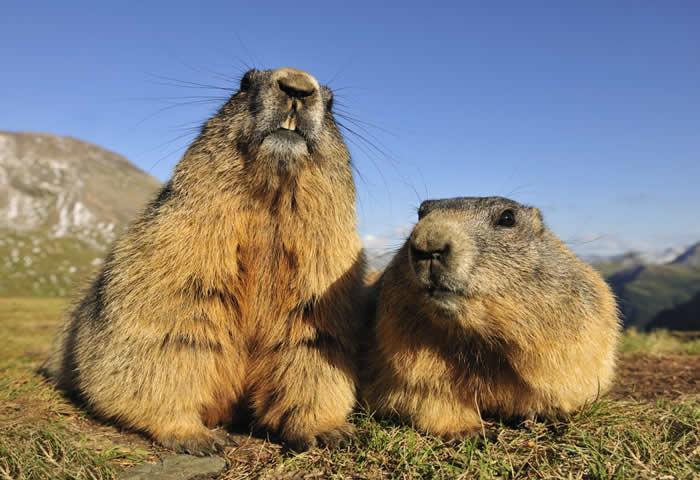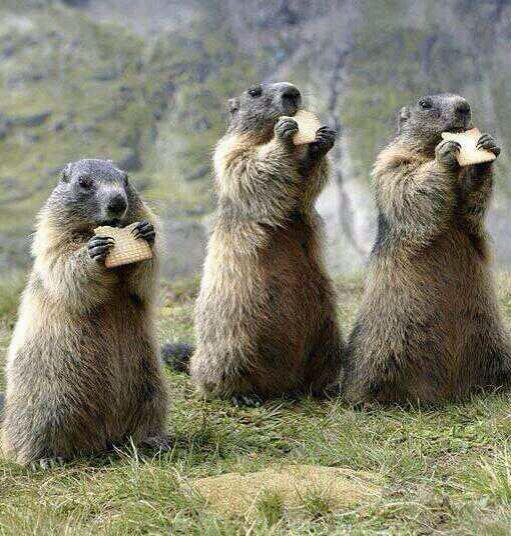The first image is the image on the left, the second image is the image on the right. For the images displayed, is the sentence "An image shows three upright marmots facing the same general direction and clutching food." factually correct? Answer yes or no. Yes. 